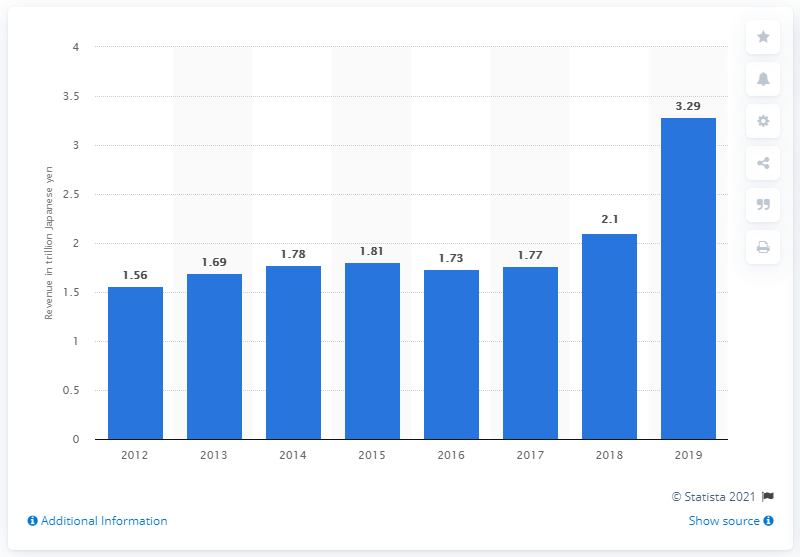Mention a couple of crucial points in this snapshot. In fiscal year 2019, Takeda Pharmaceutical Co., Ltd's revenue was 3,290... 